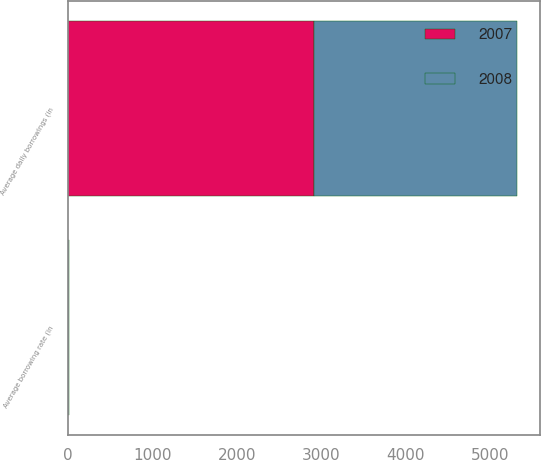Convert chart. <chart><loc_0><loc_0><loc_500><loc_500><stacked_bar_chart><ecel><fcel>Average daily borrowings (in<fcel>Average borrowing rate (in<nl><fcel>2007<fcel>2909<fcel>5.9<nl><fcel>2008<fcel>2408<fcel>6.2<nl></chart> 